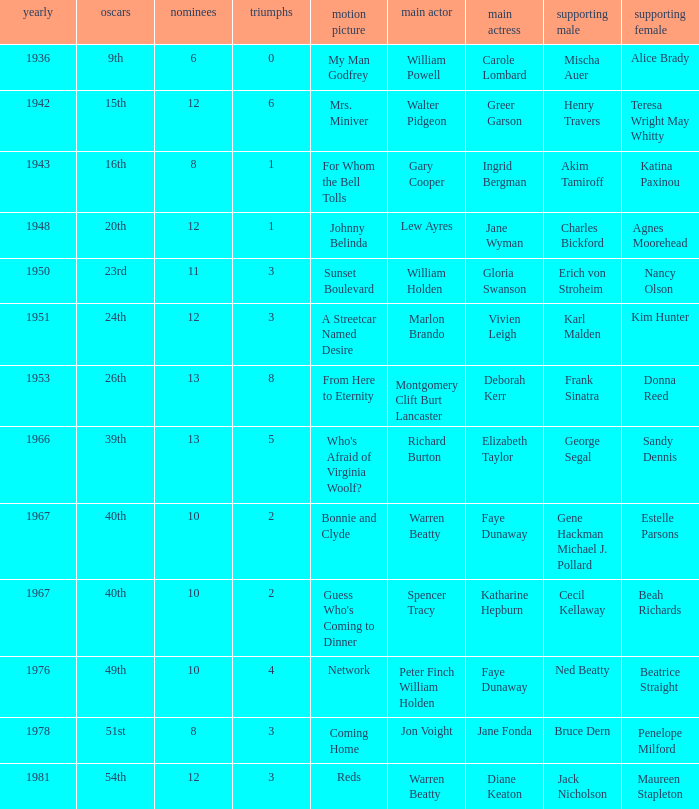Who was the supporting actress in a film with Diane Keaton as the leading actress? Maureen Stapleton. 